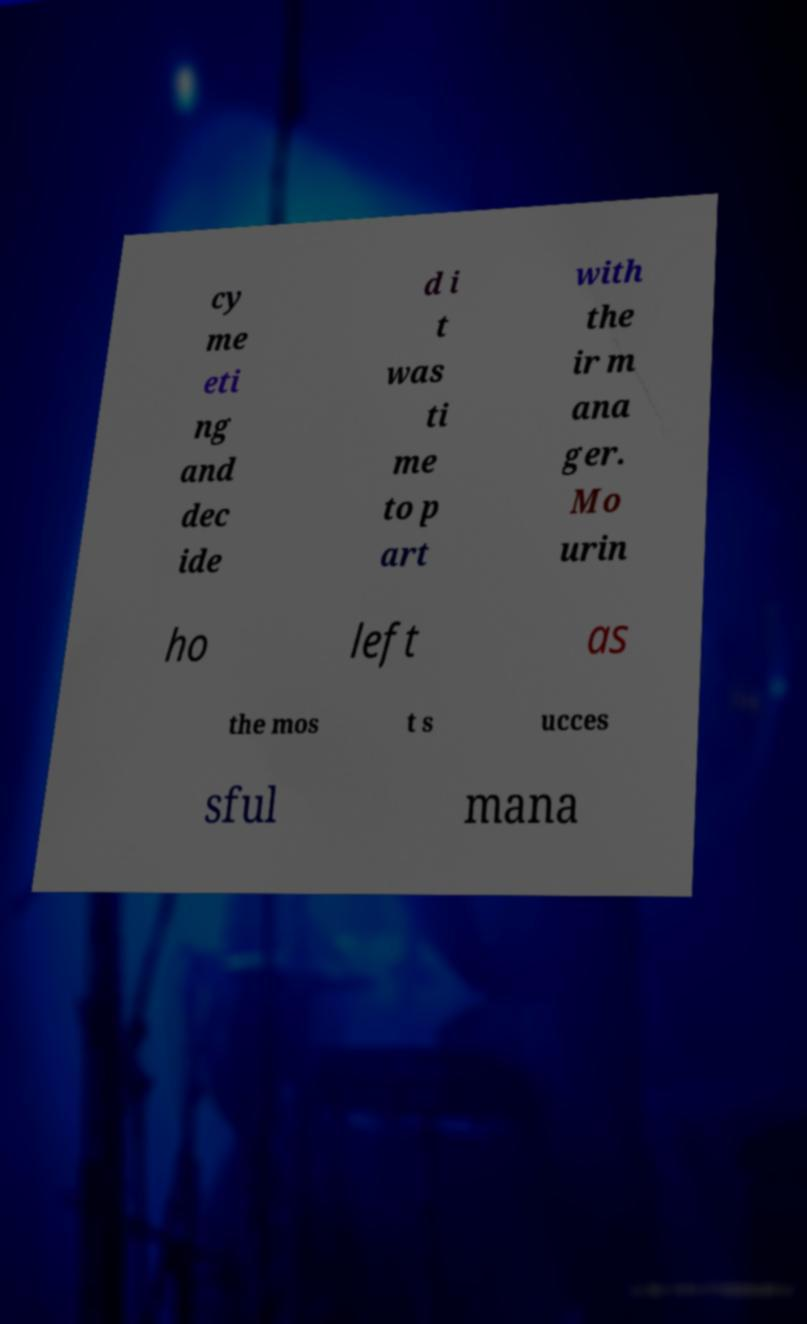Could you assist in decoding the text presented in this image and type it out clearly? cy me eti ng and dec ide d i t was ti me to p art with the ir m ana ger. Mo urin ho left as the mos t s ucces sful mana 